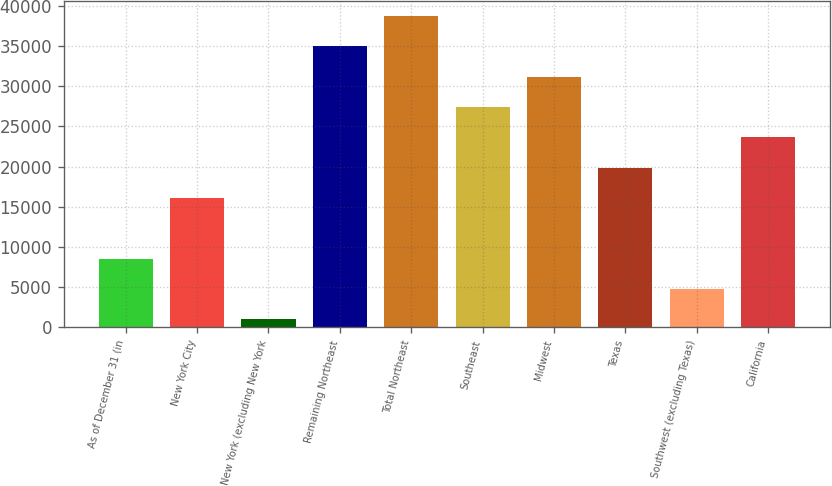<chart> <loc_0><loc_0><loc_500><loc_500><bar_chart><fcel>As of December 31 (in<fcel>New York City<fcel>New York (excluding New York<fcel>Remaining Northeast<fcel>Total Northeast<fcel>Southeast<fcel>Midwest<fcel>Texas<fcel>Southwest (excluding Texas)<fcel>California<nl><fcel>8549.4<fcel>16085.8<fcel>1013<fcel>34926.8<fcel>38695<fcel>27390.4<fcel>31158.6<fcel>19854<fcel>4781.2<fcel>23622.2<nl></chart> 